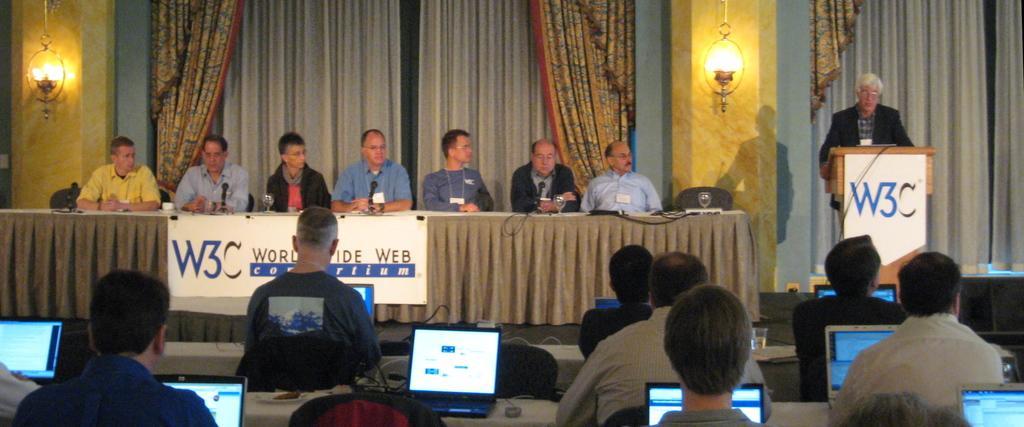How would you summarize this image in a sentence or two? The image is taken during a conference. In the foreground of the picture there are people, laptops, tables, cables, chairs and other objects. In the center of the picture it is stage, on the stage there are people, chairs, podium, table, banner, cables, mics, glasses and other objects. In the background there are curtains, lights and wall. 